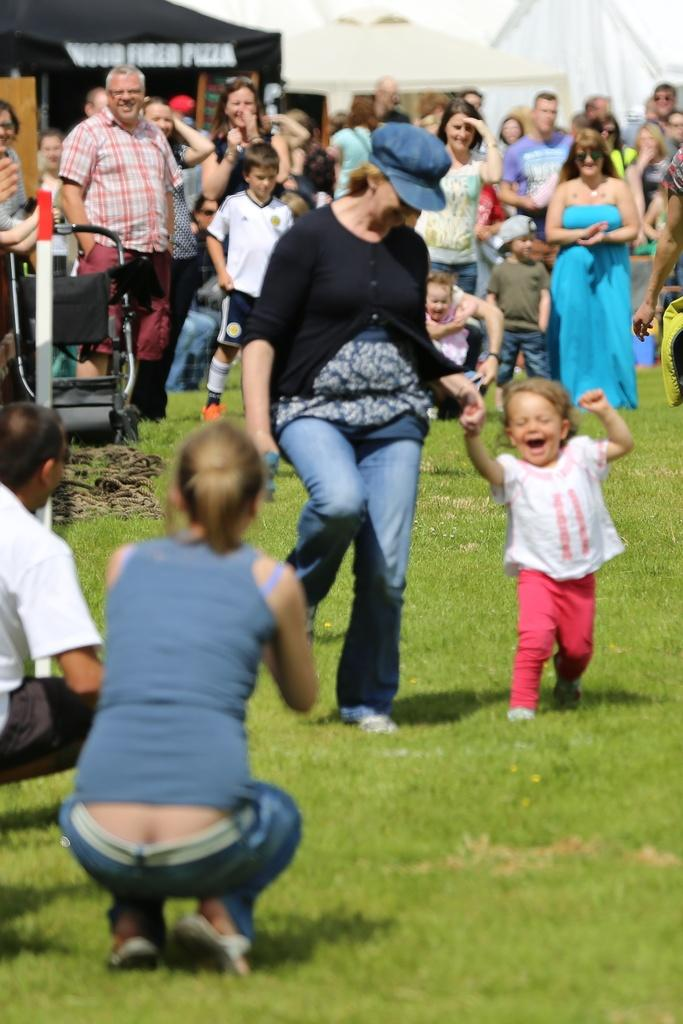What is happening in the foreground of the image? There are people on the grassland in the foreground of the image. What can be seen in the background of the image? There are houses and a sky visible in the background of the image. Can you describe the machine in the background of the image? It seems like there is a machine in the background of the image, but its specific details are not clear. What type of silver animal can be seen grazing on the grassland in the image? There is no silver animal present in the image; it features people on the grassland and houses in the background. 